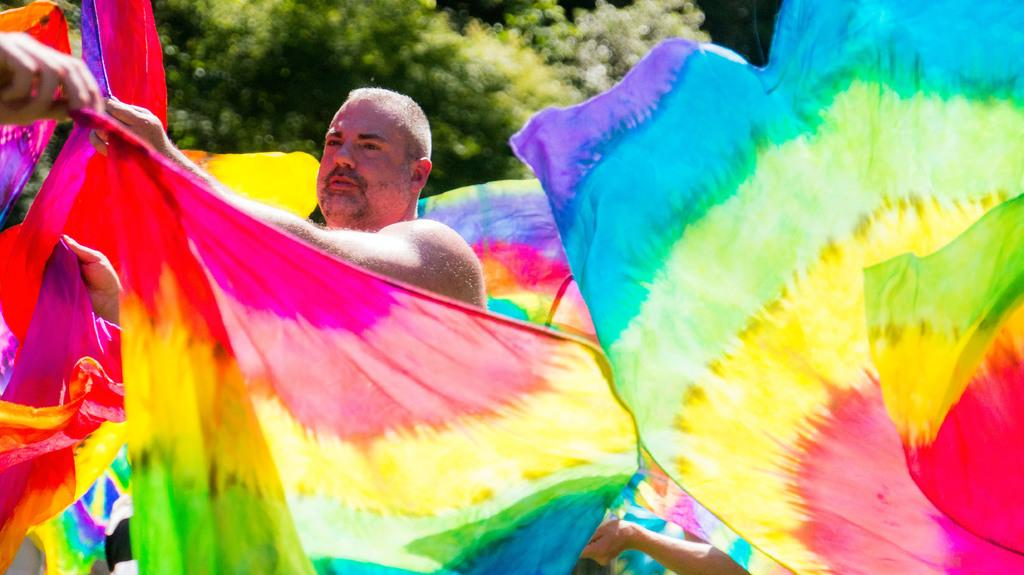Who or what is present in the image? There is a person in the image. What is the person wearing? The person is wearing rainbow-colored clothes. What natural element can be seen in the image? There is a tree visible in the image. How many thumbs can be seen on the person's hands in the image? The image does not show the person's hands or thumbs, so it cannot be determined from the image. What type of seashore can be seen in the image? There is no seashore present in the image; it features a person and a tree. 